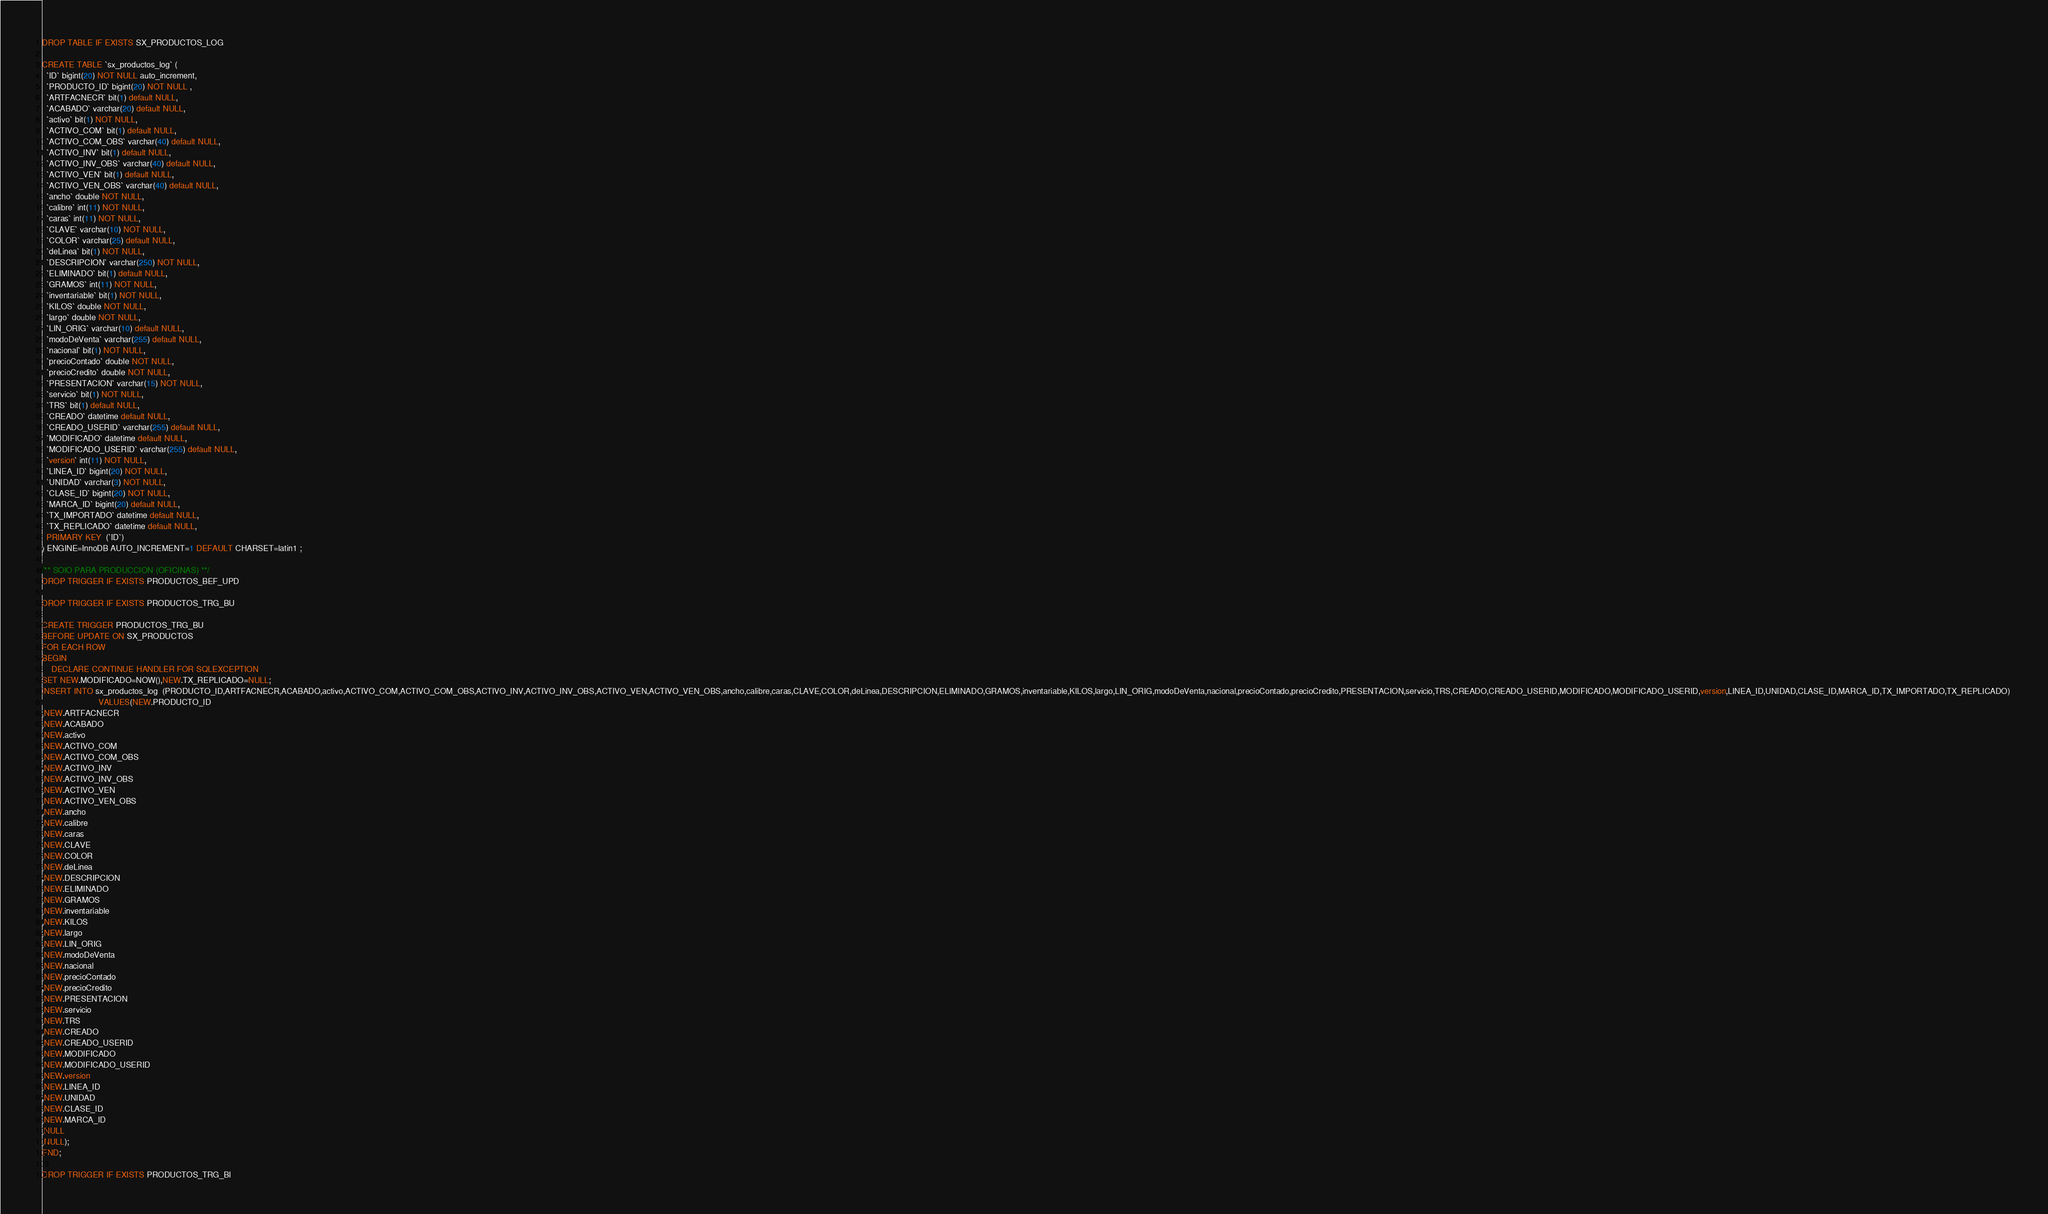Convert code to text. <code><loc_0><loc_0><loc_500><loc_500><_SQL_>DROP TABLE IF EXISTS SX_PRODUCTOS_LOG

CREATE TABLE `sx_productos_log` (
  `ID` bigint(20) NOT NULL auto_increment,
  `PRODUCTO_ID` bigint(20) NOT NULL ,
  `ARTFACNECR` bit(1) default NULL,
  `ACABADO` varchar(20) default NULL,
  `activo` bit(1) NOT NULL,
  `ACTIVO_COM` bit(1) default NULL,
  `ACTIVO_COM_OBS` varchar(40) default NULL,
  `ACTIVO_INV` bit(1) default NULL,
  `ACTIVO_INV_OBS` varchar(40) default NULL,
  `ACTIVO_VEN` bit(1) default NULL,
  `ACTIVO_VEN_OBS` varchar(40) default NULL,
  `ancho` double NOT NULL,
  `calibre` int(11) NOT NULL,
  `caras` int(11) NOT NULL,
  `CLAVE` varchar(10) NOT NULL,
  `COLOR` varchar(25) default NULL,
  `deLinea` bit(1) NOT NULL,
  `DESCRIPCION` varchar(250) NOT NULL,
  `ELIMINADO` bit(1) default NULL,
  `GRAMOS` int(11) NOT NULL,
  `inventariable` bit(1) NOT NULL,
  `KILOS` double NOT NULL,
  `largo` double NOT NULL,
  `LIN_ORIG` varchar(10) default NULL,
  `modoDeVenta` varchar(255) default NULL,
  `nacional` bit(1) NOT NULL,
  `precioContado` double NOT NULL,
  `precioCredito` double NOT NULL,
  `PRESENTACION` varchar(15) NOT NULL,
  `servicio` bit(1) NOT NULL,
  `TRS` bit(1) default NULL,
  `CREADO` datetime default NULL,
  `CREADO_USERID` varchar(255) default NULL,
  `MODIFICADO` datetime default NULL,
  `MODIFICADO_USERID` varchar(255) default NULL,
  `version` int(11) NOT NULL,
  `LINEA_ID` bigint(20) NOT NULL,
  `UNIDAD` varchar(3) NOT NULL,
  `CLASE_ID` bigint(20) NOT NULL,
  `MARCA_ID` bigint(20) default NULL,
  `TX_IMPORTADO` datetime default NULL,
  `TX_REPLICADO` datetime default NULL,
  PRIMARY KEY  (`ID`)
) ENGINE=InnoDB AUTO_INCREMENT=1 DEFAULT CHARSET=latin1 ;

/** SOlO PARA PRODUCCION (OFICINAS) **/
DROP TRIGGER IF EXISTS PRODUCTOS_BEF_UPD 

DROP TRIGGER IF EXISTS PRODUCTOS_TRG_BU

CREATE TRIGGER PRODUCTOS_TRG_BU
BEFORE UPDATE ON SX_PRODUCTOS
FOR EACH ROW 
BEGIN
	DECLARE CONTINUE HANDLER FOR SQLEXCEPTION
SET NEW.MODIFICADO=NOW(),NEW.TX_REPLICADO=NULL;
INSERT INTO sx_productos_log  (PRODUCTO_ID,ARTFACNECR,ACABADO,activo,ACTIVO_COM,ACTIVO_COM_OBS,ACTIVO_INV,ACTIVO_INV_OBS,ACTIVO_VEN,ACTIVO_VEN_OBS,ancho,calibre,caras,CLAVE,COLOR,deLinea,DESCRIPCION,ELIMINADO,GRAMOS,inventariable,KILOS,largo,LIN_ORIG,modoDeVenta,nacional,precioContado,precioCredito,PRESENTACION,servicio,TRS,CREADO,CREADO_USERID,MODIFICADO,MODIFICADO_USERID,version,LINEA_ID,UNIDAD,CLASE_ID,MARCA_ID,TX_IMPORTADO,TX_REPLICADO) 
                        VALUES(NEW.PRODUCTO_ID
,NEW.ARTFACNECR
,NEW.ACABADO
,NEW.activo
,NEW.ACTIVO_COM
,NEW.ACTIVO_COM_OBS
,NEW.ACTIVO_INV
,NEW.ACTIVO_INV_OBS
,NEW.ACTIVO_VEN
,NEW.ACTIVO_VEN_OBS
,NEW.ancho
,NEW.calibre
,NEW.caras
,NEW.CLAVE
,NEW.COLOR
,NEW.deLinea
,NEW.DESCRIPCION
,NEW.ELIMINADO
,NEW.GRAMOS
,NEW.inventariable
,NEW.KILOS
,NEW.largo
,NEW.LIN_ORIG
,NEW.modoDeVenta
,NEW.nacional
,NEW.precioContado
,NEW.precioCredito
,NEW.PRESENTACION
,NEW.servicio
,NEW.TRS
,NEW.CREADO
,NEW.CREADO_USERID
,NEW.MODIFICADO
,NEW.MODIFICADO_USERID
,NEW.version
,NEW.LINEA_ID
,NEW.UNIDAD
,NEW.CLASE_ID
,NEW.MARCA_ID
,NULL
,NULL);
END;

DROP TRIGGER IF EXISTS PRODUCTOS_TRG_BI
</code> 